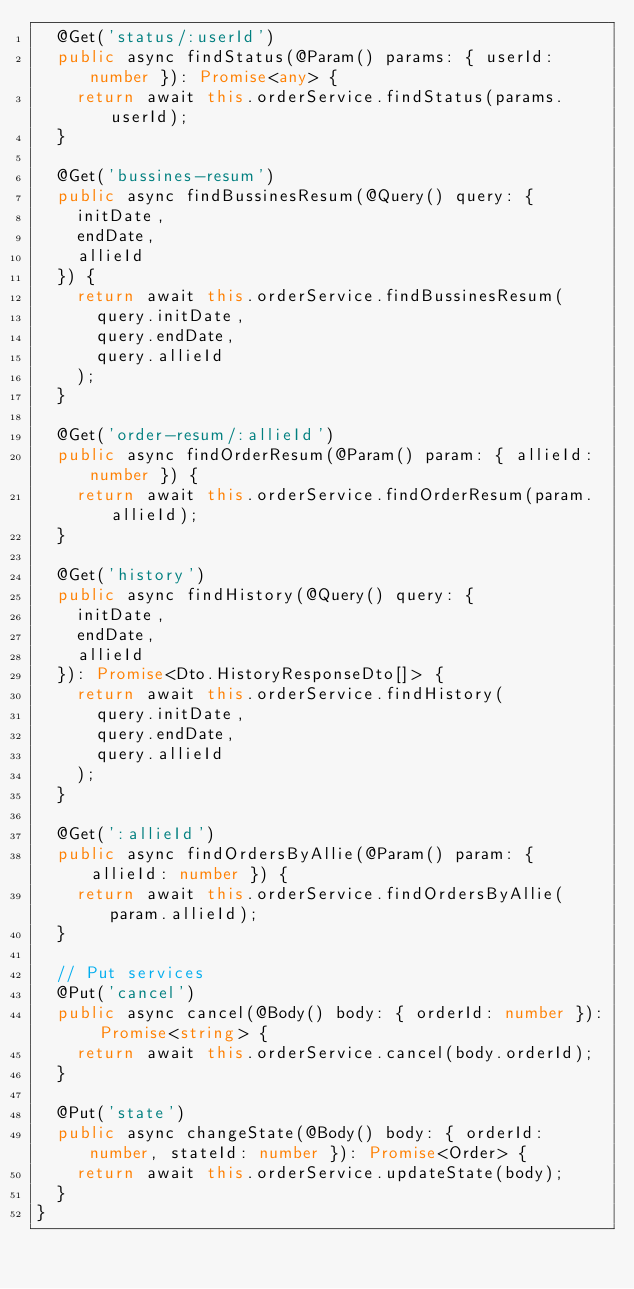<code> <loc_0><loc_0><loc_500><loc_500><_TypeScript_>  @Get('status/:userId')
  public async findStatus(@Param() params: { userId: number }): Promise<any> {
    return await this.orderService.findStatus(params.userId);
  }

  @Get('bussines-resum')
  public async findBussinesResum(@Query() query: {
    initDate,
    endDate,
    allieId
  }) {
    return await this.orderService.findBussinesResum(
      query.initDate,
      query.endDate,
      query.allieId
    );
  }

  @Get('order-resum/:allieId')
  public async findOrderResum(@Param() param: { allieId: number }) {
    return await this.orderService.findOrderResum(param.allieId);
  }

  @Get('history')
  public async findHistory(@Query() query: {
    initDate,
    endDate,
    allieId
  }): Promise<Dto.HistoryResponseDto[]> {
    return await this.orderService.findHistory(
      query.initDate,
      query.endDate,
      query.allieId
    );
  }

  @Get(':allieId')
  public async findOrdersByAllie(@Param() param: { allieId: number }) {
    return await this.orderService.findOrdersByAllie(param.allieId);
  }

  // Put services
  @Put('cancel')
  public async cancel(@Body() body: { orderId: number }): Promise<string> {
    return await this.orderService.cancel(body.orderId);
  }

  @Put('state')
  public async changeState(@Body() body: { orderId: number, stateId: number }): Promise<Order> {
    return await this.orderService.updateState(body);
  }
}
</code> 